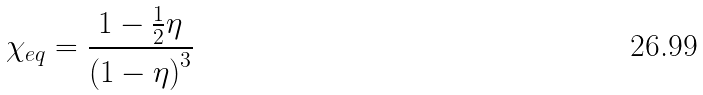Convert formula to latex. <formula><loc_0><loc_0><loc_500><loc_500>\chi _ { e q } = \frac { 1 - \frac { 1 } { 2 } \eta } { \left ( 1 - \eta \right ) ^ { 3 } }</formula> 